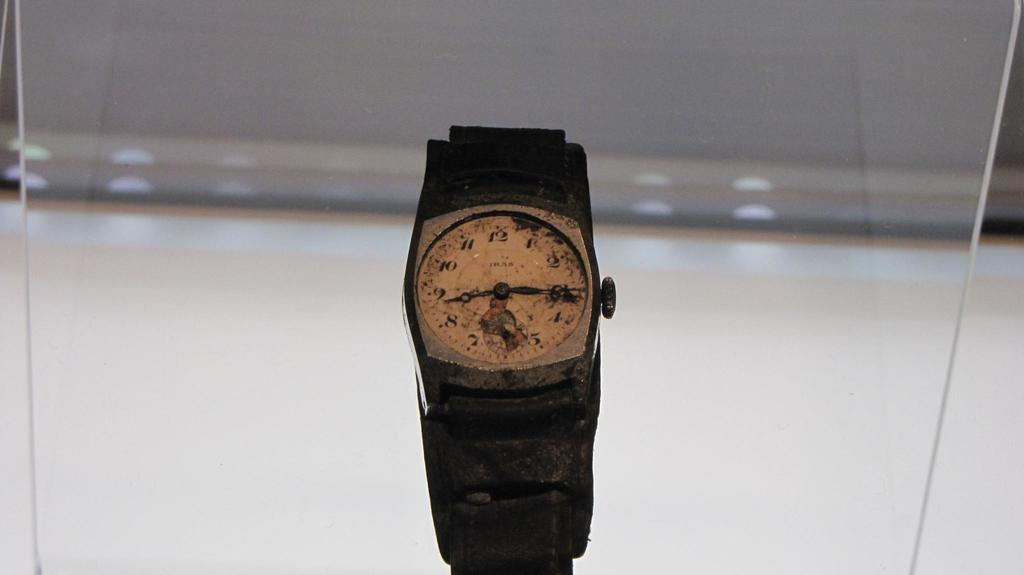<image>
Present a compact description of the photo's key features. an old cracked watch face has TRAS on it 